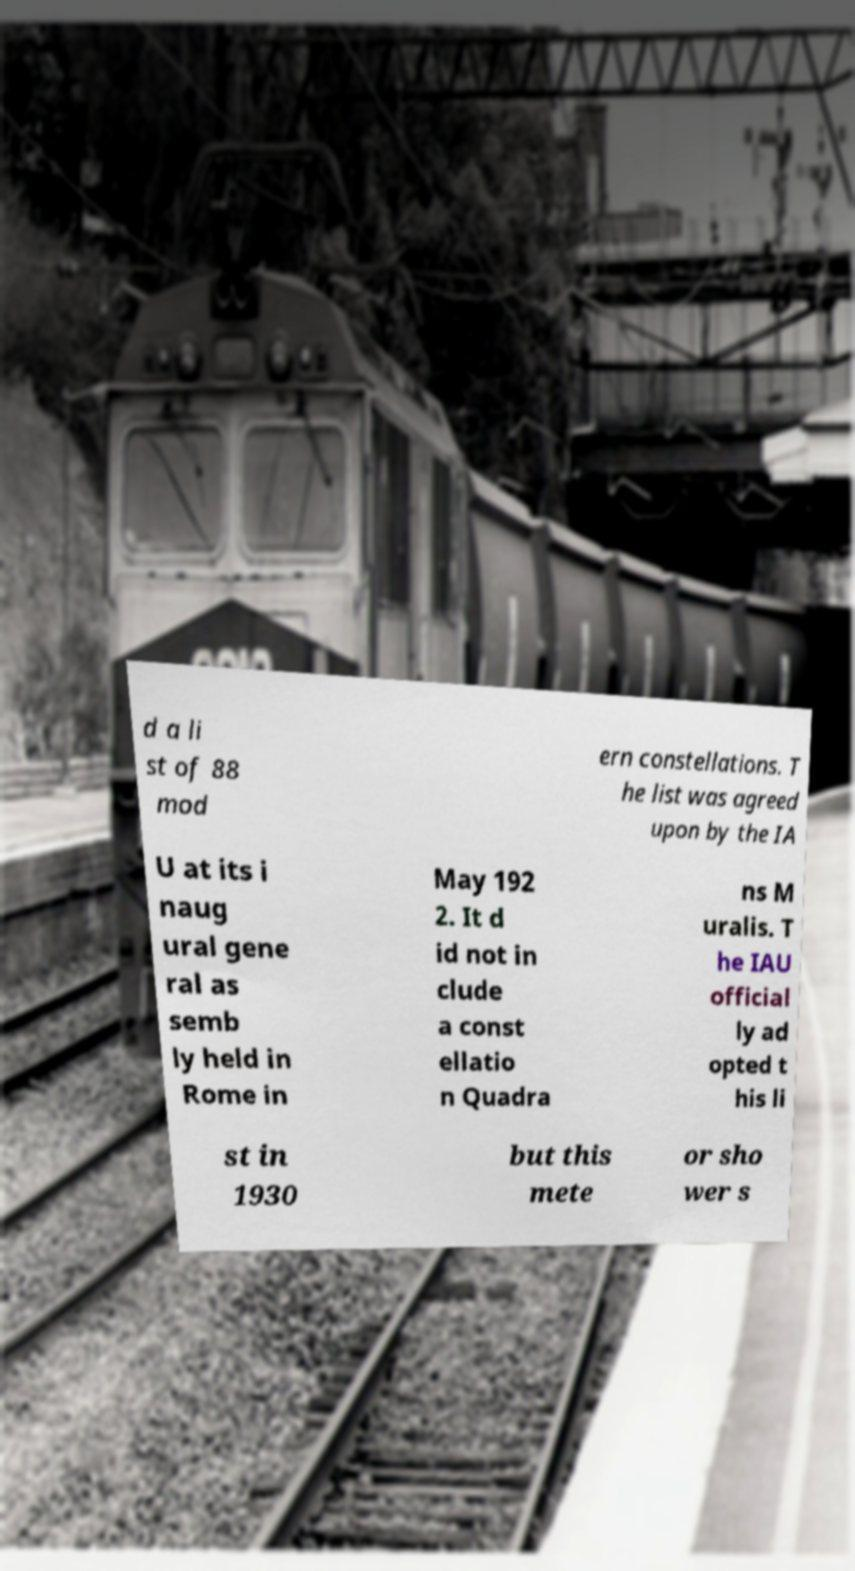Can you read and provide the text displayed in the image?This photo seems to have some interesting text. Can you extract and type it out for me? d a li st of 88 mod ern constellations. T he list was agreed upon by the IA U at its i naug ural gene ral as semb ly held in Rome in May 192 2. It d id not in clude a const ellatio n Quadra ns M uralis. T he IAU official ly ad opted t his li st in 1930 but this mete or sho wer s 